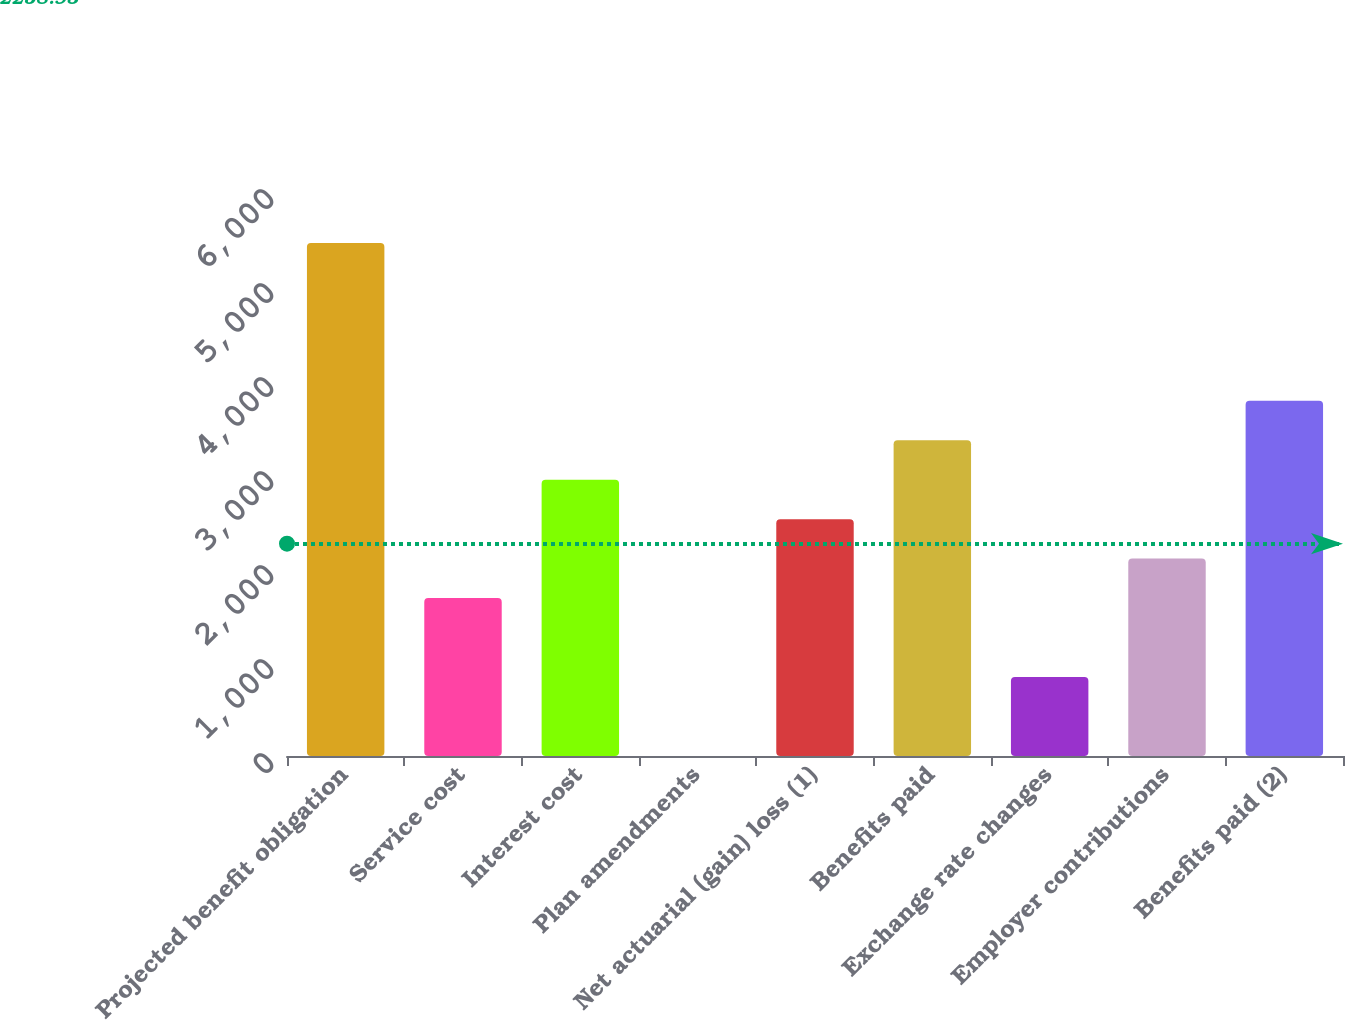Convert chart to OTSL. <chart><loc_0><loc_0><loc_500><loc_500><bar_chart><fcel>Projected benefit obligation<fcel>Service cost<fcel>Interest cost<fcel>Plan amendments<fcel>Net actuarial (gain) loss (1)<fcel>Benefits paid<fcel>Exchange rate changes<fcel>Employer contributions<fcel>Benefits paid (2)<nl><fcel>5458.4<fcel>1680.2<fcel>2939.6<fcel>1<fcel>2519.8<fcel>3359.4<fcel>840.6<fcel>2100<fcel>3779.2<nl></chart> 